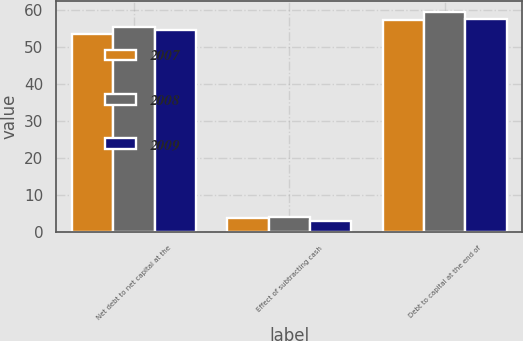Convert chart to OTSL. <chart><loc_0><loc_0><loc_500><loc_500><stacked_bar_chart><ecel><fcel>Net debt to net capital at the<fcel>Effect of subtracting cash<fcel>Debt to capital at the end of<nl><fcel>2007<fcel>53.5<fcel>3.8<fcel>57.3<nl><fcel>2008<fcel>55.6<fcel>4.1<fcel>59.7<nl><fcel>2009<fcel>54.7<fcel>2.9<fcel>57.6<nl></chart> 